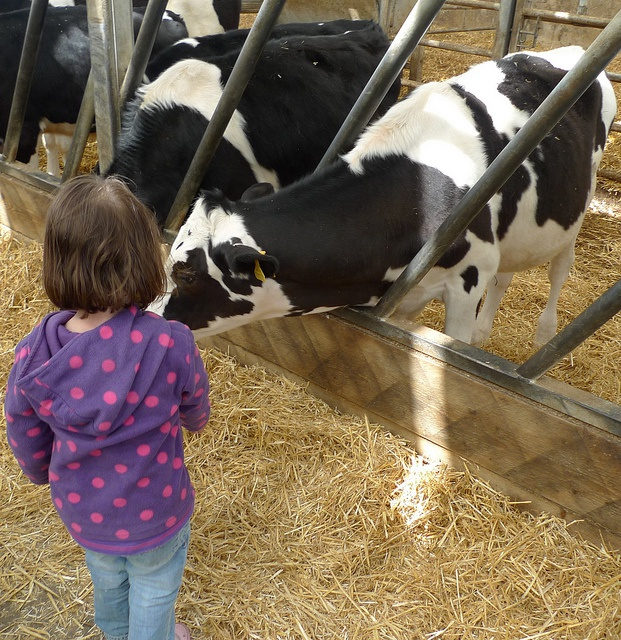Describe the objects in this image and their specific colors. I can see cow in black, white, tan, and darkgray tones, people in black and purple tones, cow in black, beige, gray, and darkgray tones, cow in black and gray tones, and cow in black, gray, darkgray, and ivory tones in this image. 